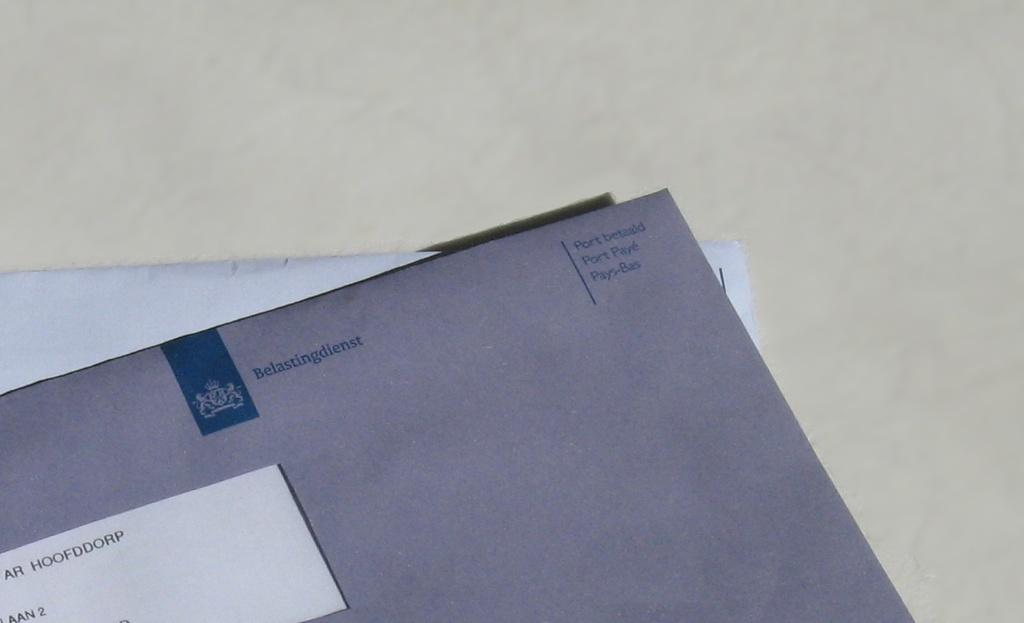<image>
Provide a brief description of the given image. a grey envelop without a stamp with the phrase belastingdiens written in blue 